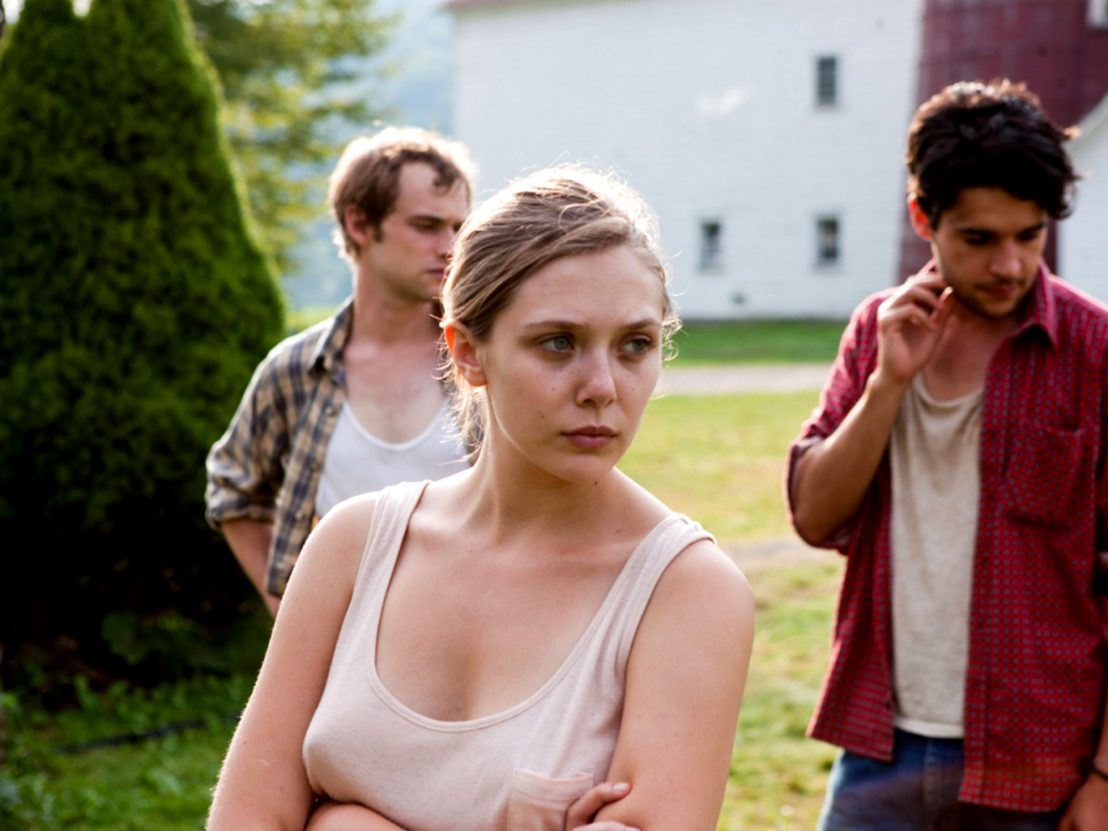Can you describe the emotions of the characters in the scene? The central character, a woman with her arms crossed, appears deeply concerned or pensive. Her furrowed brow and distant gaze suggest she is contemplating something serious or troubling. The man on her left, dressed in a plaid shirt, looks somewhat worried or confused, his gaze directed downward. Meanwhile, the man on her right, wearing a red shirt, seems to be in a moment of hesitation or contemplation, indicated by his hand scratching his neck and his downcast eyes. Together, their body language and expressions create an atmosphere of tension and unease, hinting at an underlying conflict or significant issue they are grappling with. 